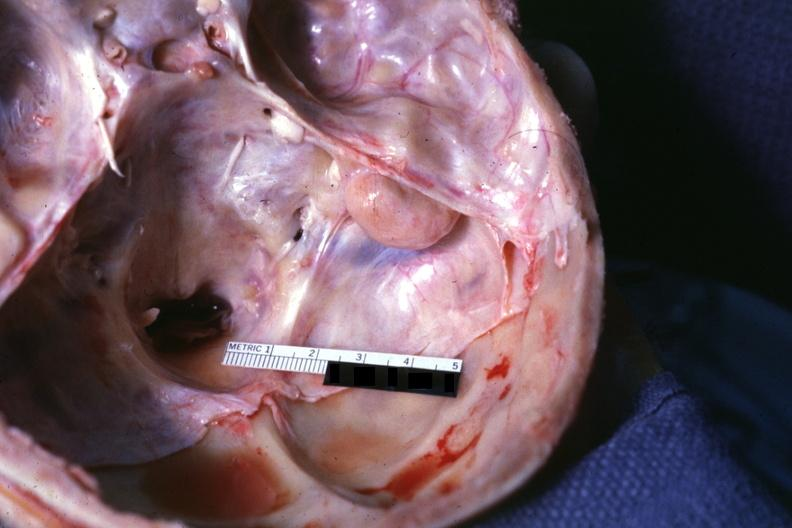how is lesion seen on surface petrous bone?
Answer the question using a single word or phrase. Right 